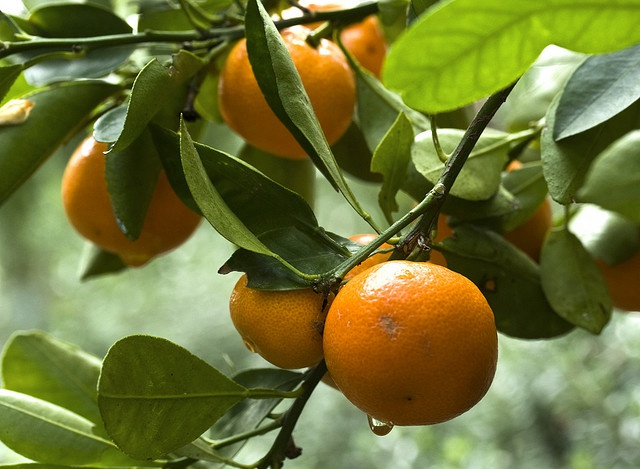Describe the objects in this image and their specific colors. I can see orange in white, maroon, brown, and orange tones, orange in white, maroon, olive, and black tones, orange in white, maroon, olive, and orange tones, orange in white, olive, maroon, and black tones, and orange in white, black, olive, orange, and maroon tones in this image. 